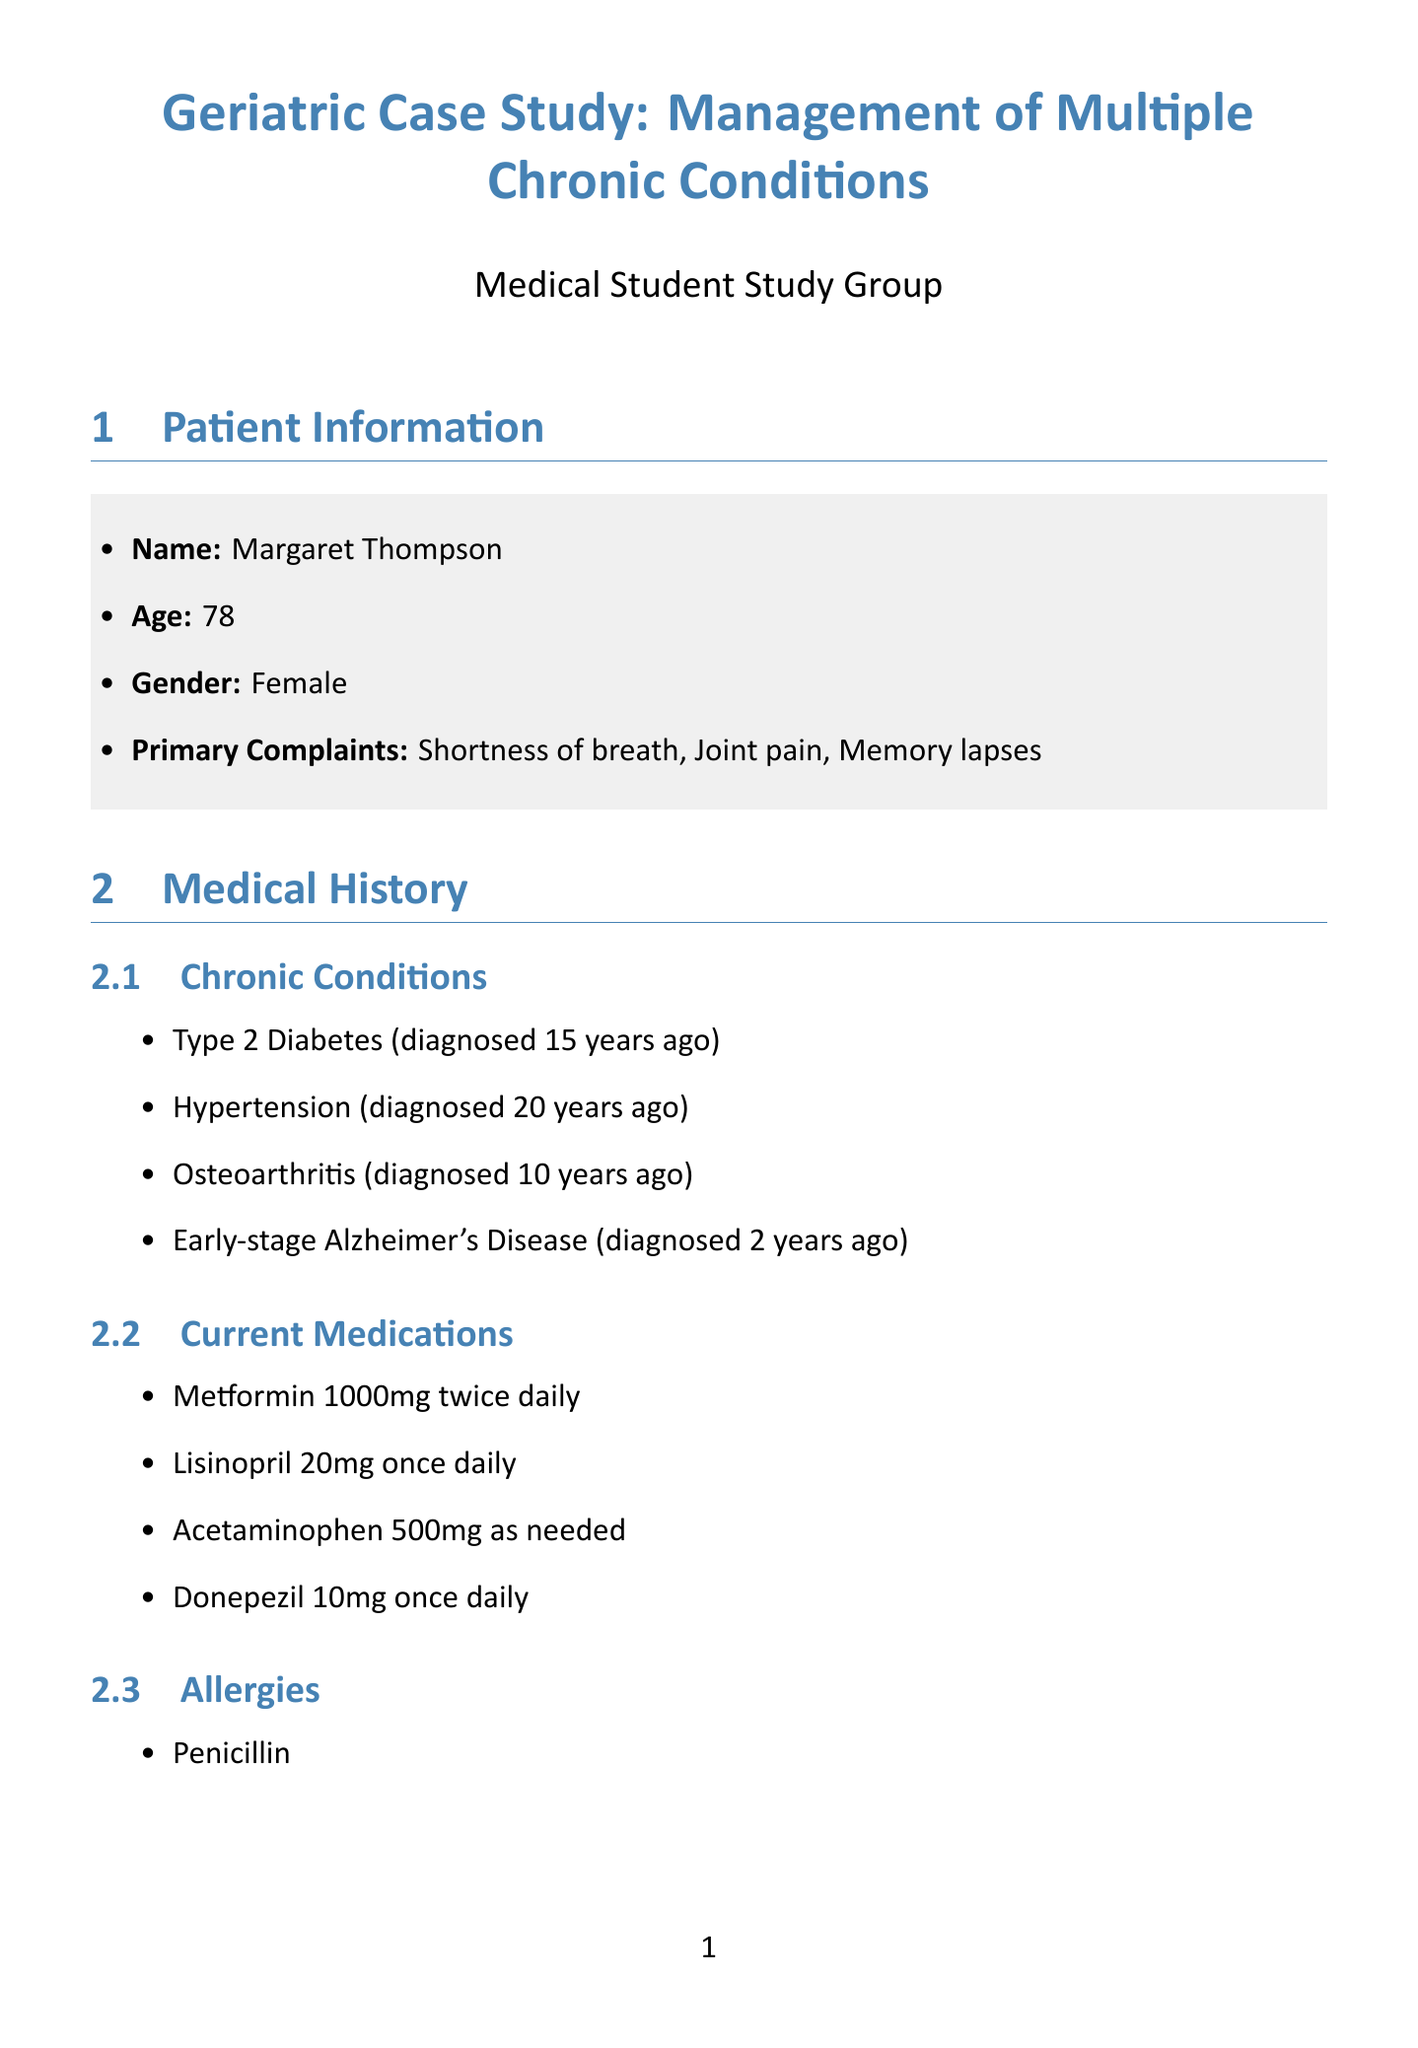What is the patient's age? The patient's age is stated in the document as part of her personal information.
Answer: 78 Who is the primary care physician? The document lists the primary care physician as part of the interprofessional collaboration section.
Answer: Dr. Sarah Chen What medication is prescribed for hypertension? The treatment plan for hypertension management details the medications recommended for the patient's condition.
Answer: Amlodipine 5mg once daily What is the MMSE score indicating? The document specifies the MMSE score and what it signifies in the context of the neurological assessment.
Answer: Mild cognitive impairment How often will the patient have primary care follow-ups? The follow-up plan section indicates the frequency of primary care appointments.
Answer: Every 3 months What type of therapy is planned for osteoarthritis management? The osteoarthritis management section of the treatment plan describes the type of therapy included for the patient's knee pain.
Answer: Physical Therapy What is the frequency of care conferences? The interprofessional collaboration section outlines the scheduled frequency for team meetings concerning the patient.
Answer: Monthly 